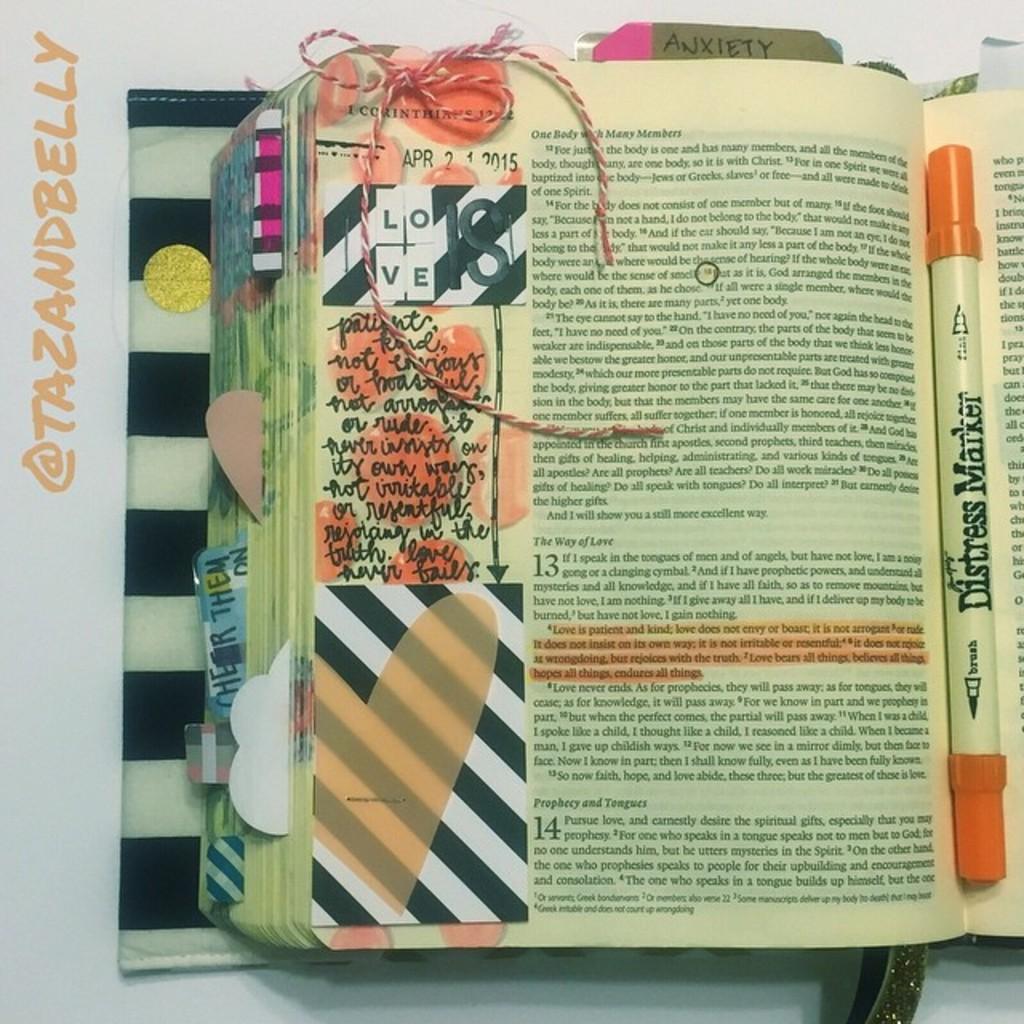What is the name of the highlighter in the book?
Your answer should be very brief. Distress marker. What is the word following the @ symbol on the left side of the page?
Keep it short and to the point. Tazandbelly. 